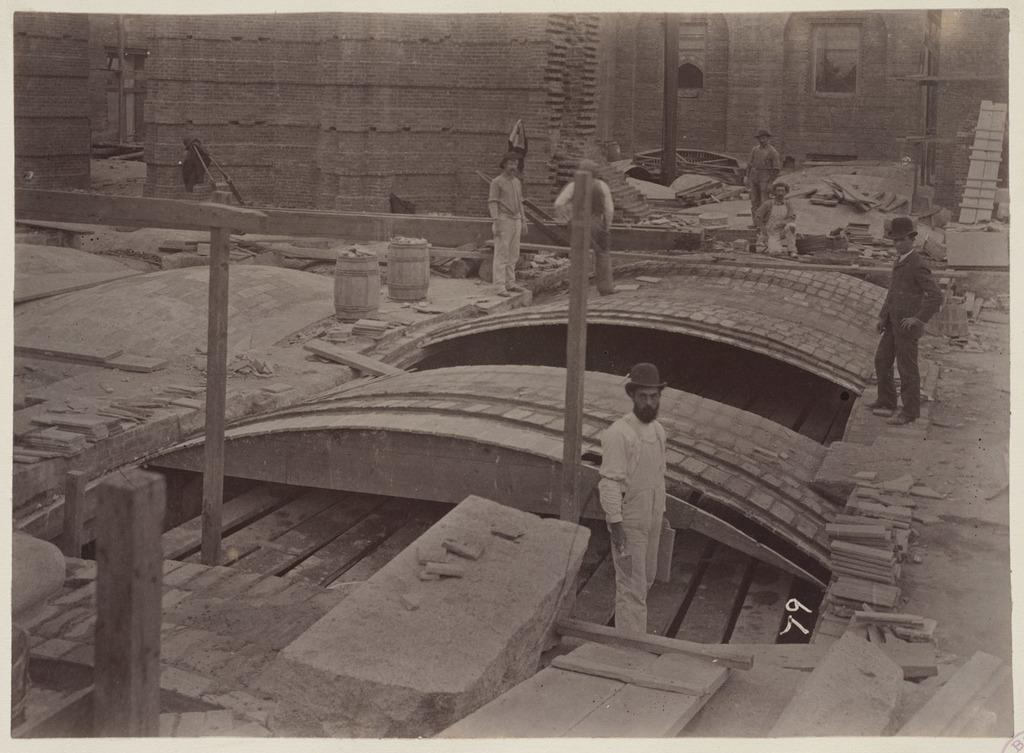What is the color scheme of the image? The image is a black and white photo. Who or what can be seen in the image? There are persons in the image. What structure is present in the image? There is a bridge in the image. What musical instruments are visible in the image? There are drums in the image. What architectural feature can be seen in the image? There is a wall in the image. What material is used to construct the wall? There are bricks in the image. What supports the bridge or other structures in the image? There are poles in the image. What surface is visible in the image? There is a floor in the image. What type of natural element is present in the image? There are rocks in the image. What type of table is used to serve the potatoes in the image? There is no table or potatoes present in the image. What type of brass instrument is being played by the persons in the image? There is no brass instrument visible in the image; only drums are mentioned. 